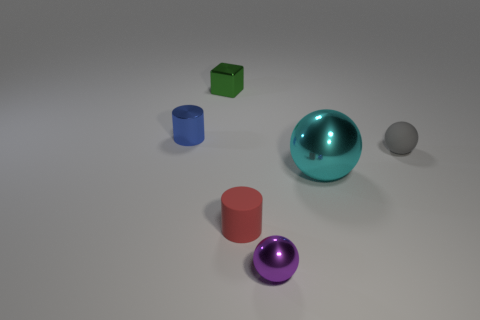Add 3 small purple metallic objects. How many objects exist? 9 Subtract 1 blue cylinders. How many objects are left? 5 Subtract all cylinders. How many objects are left? 4 Subtract all tiny metallic cylinders. Subtract all small gray objects. How many objects are left? 4 Add 4 small blue objects. How many small blue objects are left? 5 Add 1 green cubes. How many green cubes exist? 2 